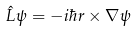Convert formula to latex. <formula><loc_0><loc_0><loc_500><loc_500>\hat { L } \psi = - i \hbar { r } \times \nabla \psi</formula> 